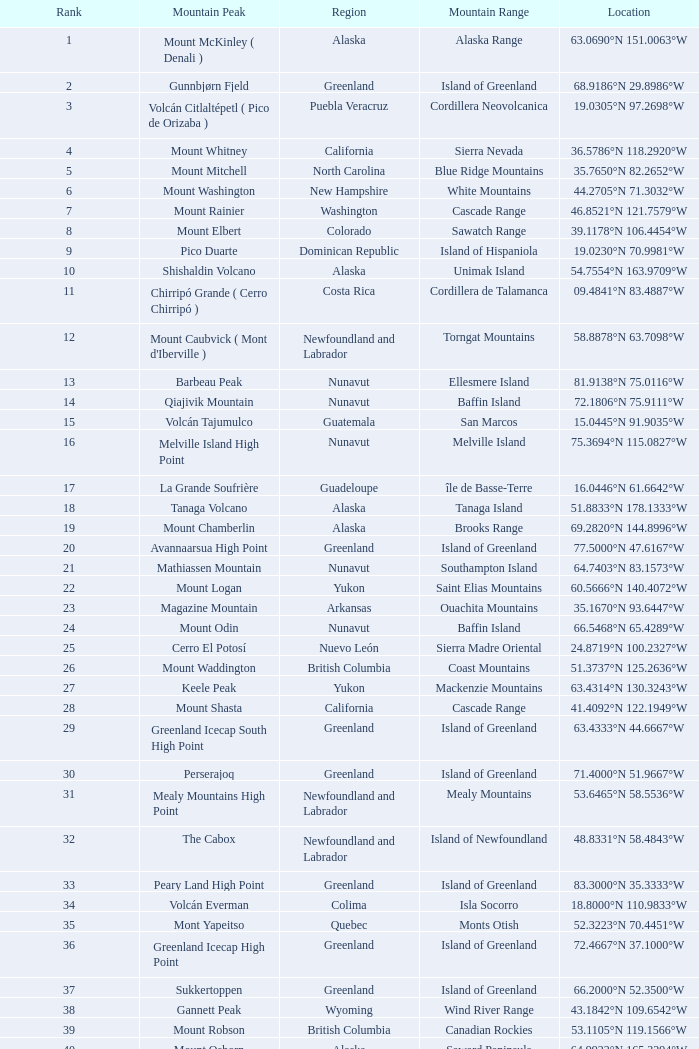Which Mountain Range has a Region of haiti, and a Location of 18.3601°n 71.9764°w? Island of Hispaniola. 